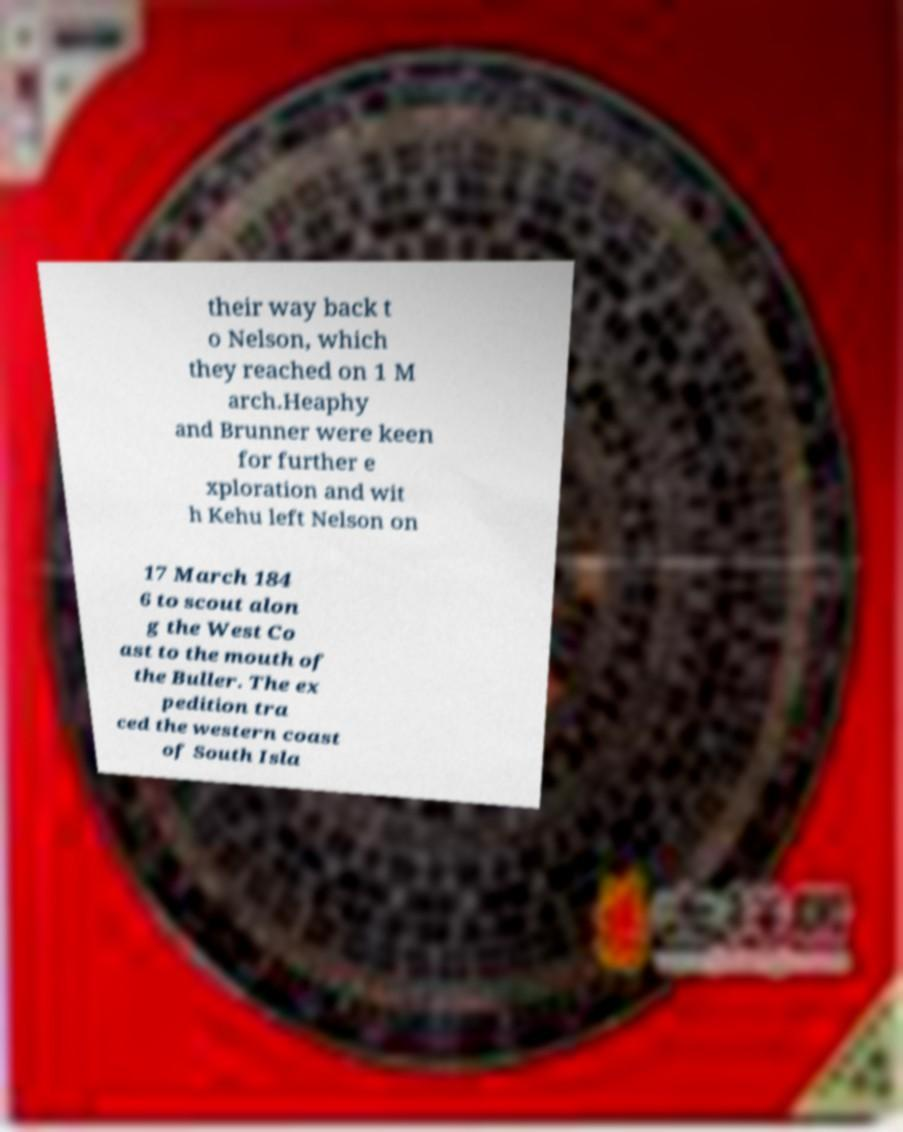Please identify and transcribe the text found in this image. their way back t o Nelson, which they reached on 1 M arch.Heaphy and Brunner were keen for further e xploration and wit h Kehu left Nelson on 17 March 184 6 to scout alon g the West Co ast to the mouth of the Buller. The ex pedition tra ced the western coast of South Isla 